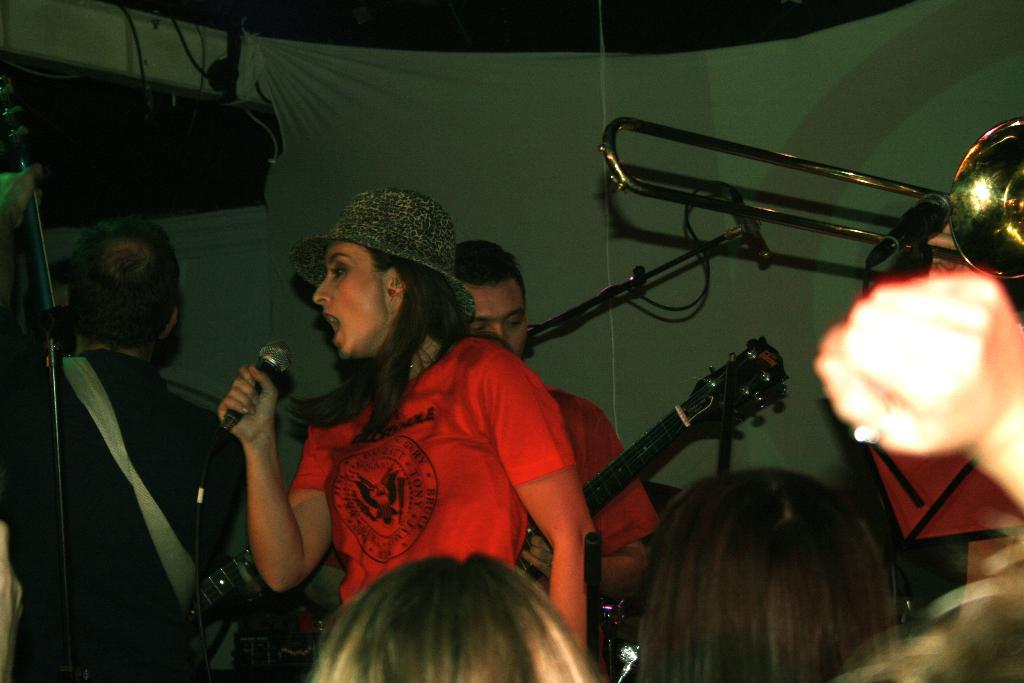What is the main subject of the image? The main subject of the image is a woman. What is the woman doing in the image? The woman is singing on a microphone. Can you describe the woman's attire? The woman is wearing a cap. What are the two persons in the background doing? The two persons in the background are playing guitar. What type of steel is used to make the connection between the microphone and the woman's cap? There is no mention of steel or a connection between the microphone and the woman's cap in the image. 